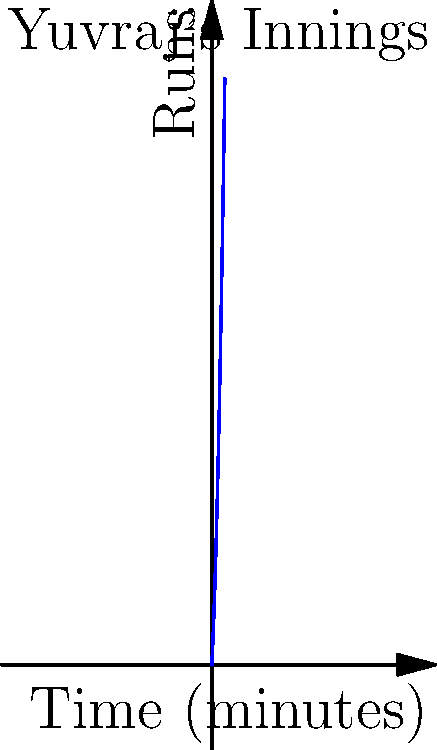Yuvraj Singh's run accumulation during an innings can be modeled by the function $R(t) = 0.5t^2 + 20t$, where $R$ represents the total runs scored and $t$ is the time in minutes. Calculate Yuvraj's instantaneous run rate at $t = 30$ minutes. To find the instantaneous run rate at a specific point, we need to calculate the derivative of the given function and evaluate it at the given time.

1. Given function: $R(t) = 0.5t^2 + 20t$

2. Find the derivative $R'(t)$:
   $R'(t) = \frac{d}{dt}(0.5t^2 + 20t)$
   $R'(t) = 0.5 \cdot 2t + 20$
   $R'(t) = t + 20$

3. The derivative $R'(t)$ represents the instantaneous run rate at any given time $t$.

4. Evaluate $R'(t)$ at $t = 30$:
   $R'(30) = 30 + 20 = 50$

Therefore, Yuvraj's instantaneous run rate at $t = 30$ minutes is 50 runs per minute.
Answer: 50 runs per minute 